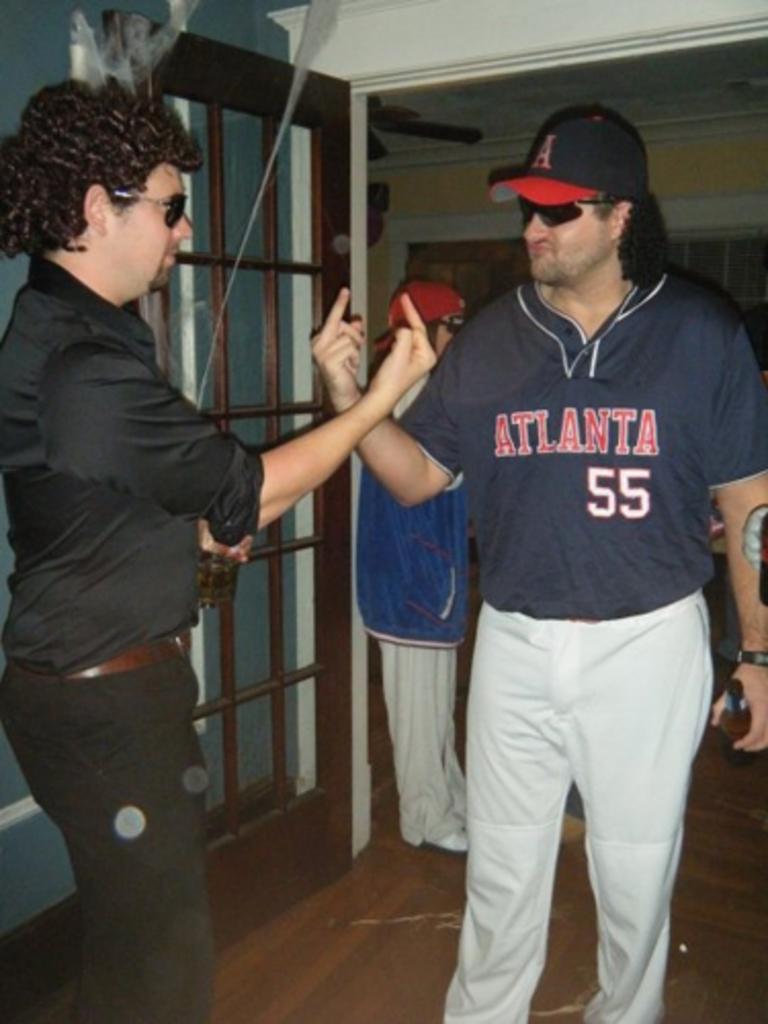Atlanta city usa?
Offer a terse response. Yes. 